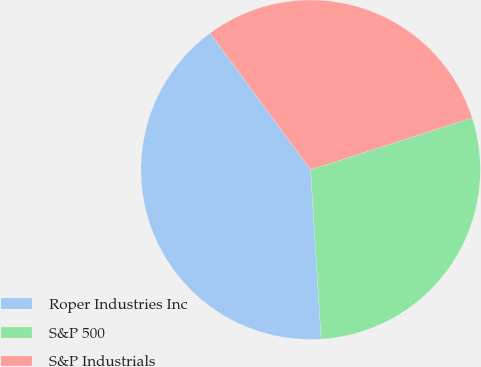Convert chart to OTSL. <chart><loc_0><loc_0><loc_500><loc_500><pie_chart><fcel>Roper Industries Inc<fcel>S&P 500<fcel>S&P Industrials<nl><fcel>40.89%<fcel>28.96%<fcel>30.15%<nl></chart> 